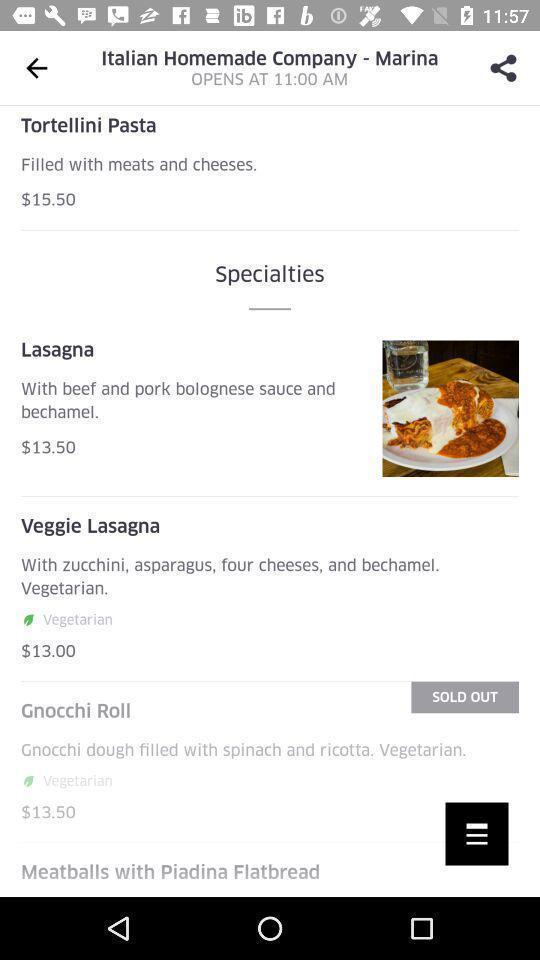Summarize the information in this screenshot. Screen showing specialities in an food application. 